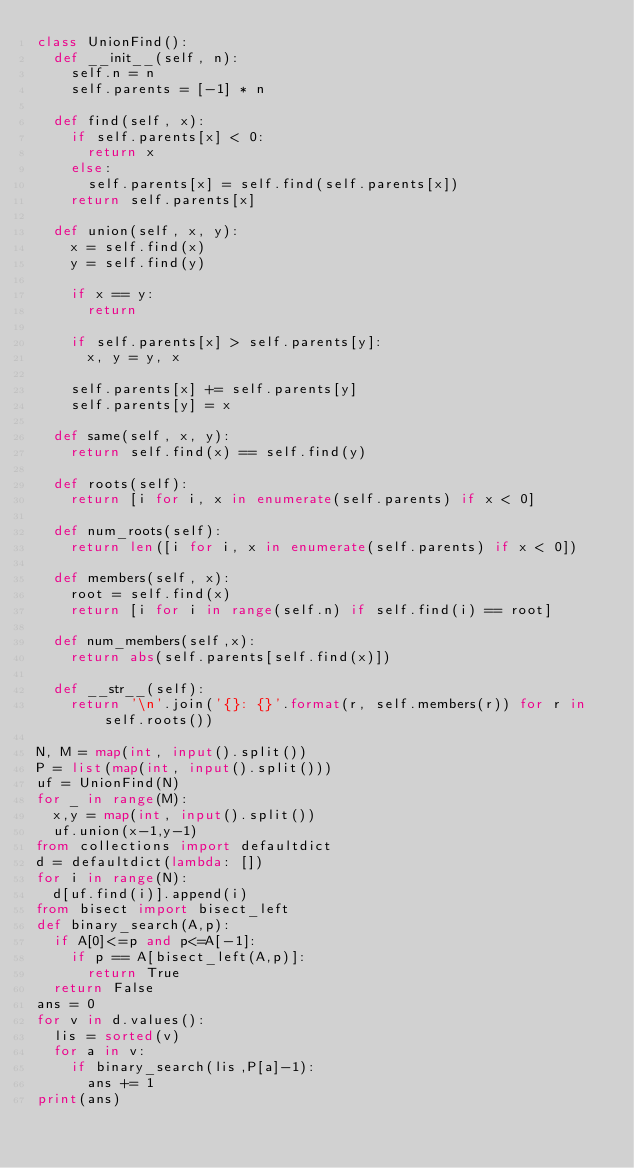Convert code to text. <code><loc_0><loc_0><loc_500><loc_500><_Python_>class UnionFind():
  def __init__(self, n):
    self.n = n
    self.parents = [-1] * n

  def find(self, x):
    if self.parents[x] < 0:
      return x
    else:
      self.parents[x] = self.find(self.parents[x])
    return self.parents[x]

  def union(self, x, y):
    x = self.find(x)
    y = self.find(y)

    if x == y:
      return

    if self.parents[x] > self.parents[y]:
      x, y = y, x

    self.parents[x] += self.parents[y]
    self.parents[y] = x

  def same(self, x, y):
    return self.find(x) == self.find(y)

  def roots(self):
    return [i for i, x in enumerate(self.parents) if x < 0]

  def num_roots(self):
    return len([i for i, x in enumerate(self.parents) if x < 0])

  def members(self, x):
    root = self.find(x)
    return [i for i in range(self.n) if self.find(i) == root]

  def num_members(self,x):
    return abs(self.parents[self.find(x)])

  def __str__(self):
    return '\n'.join('{}: {}'.format(r, self.members(r)) for r in self.roots())

N, M = map(int, input().split())
P = list(map(int, input().split()))
uf = UnionFind(N)
for _ in range(M):
  x,y = map(int, input().split())
  uf.union(x-1,y-1)
from collections import defaultdict
d = defaultdict(lambda: [])
for i in range(N):
  d[uf.find(i)].append(i)
from bisect import bisect_left
def binary_search(A,p):
  if A[0]<=p and p<=A[-1]:
    if p == A[bisect_left(A,p)]:
      return True
  return False
ans = 0
for v in d.values():
  lis = sorted(v)
  for a in v:
    if binary_search(lis,P[a]-1):
      ans += 1
print(ans)



</code> 